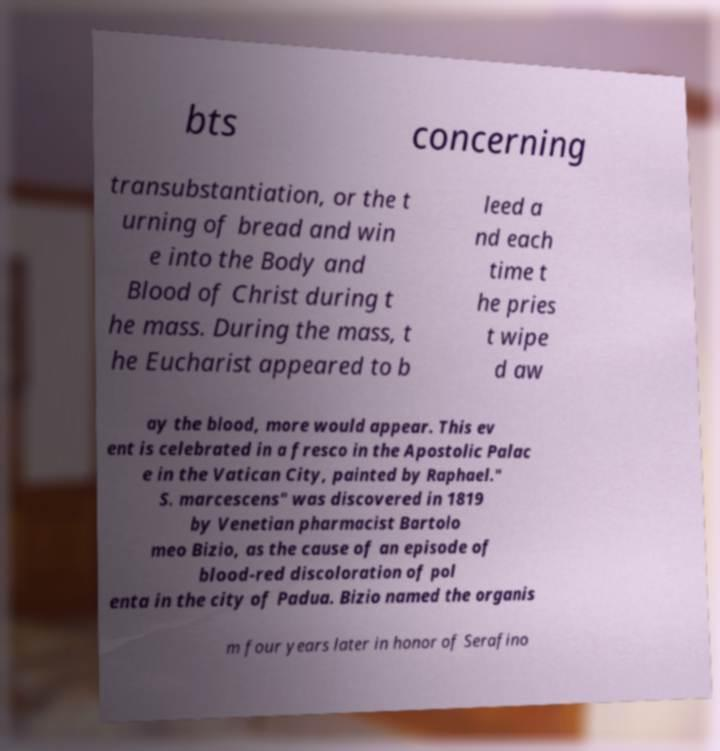Please read and relay the text visible in this image. What does it say? bts concerning transubstantiation, or the t urning of bread and win e into the Body and Blood of Christ during t he mass. During the mass, t he Eucharist appeared to b leed a nd each time t he pries t wipe d aw ay the blood, more would appear. This ev ent is celebrated in a fresco in the Apostolic Palac e in the Vatican City, painted by Raphael." S. marcescens" was discovered in 1819 by Venetian pharmacist Bartolo meo Bizio, as the cause of an episode of blood-red discoloration of pol enta in the city of Padua. Bizio named the organis m four years later in honor of Serafino 